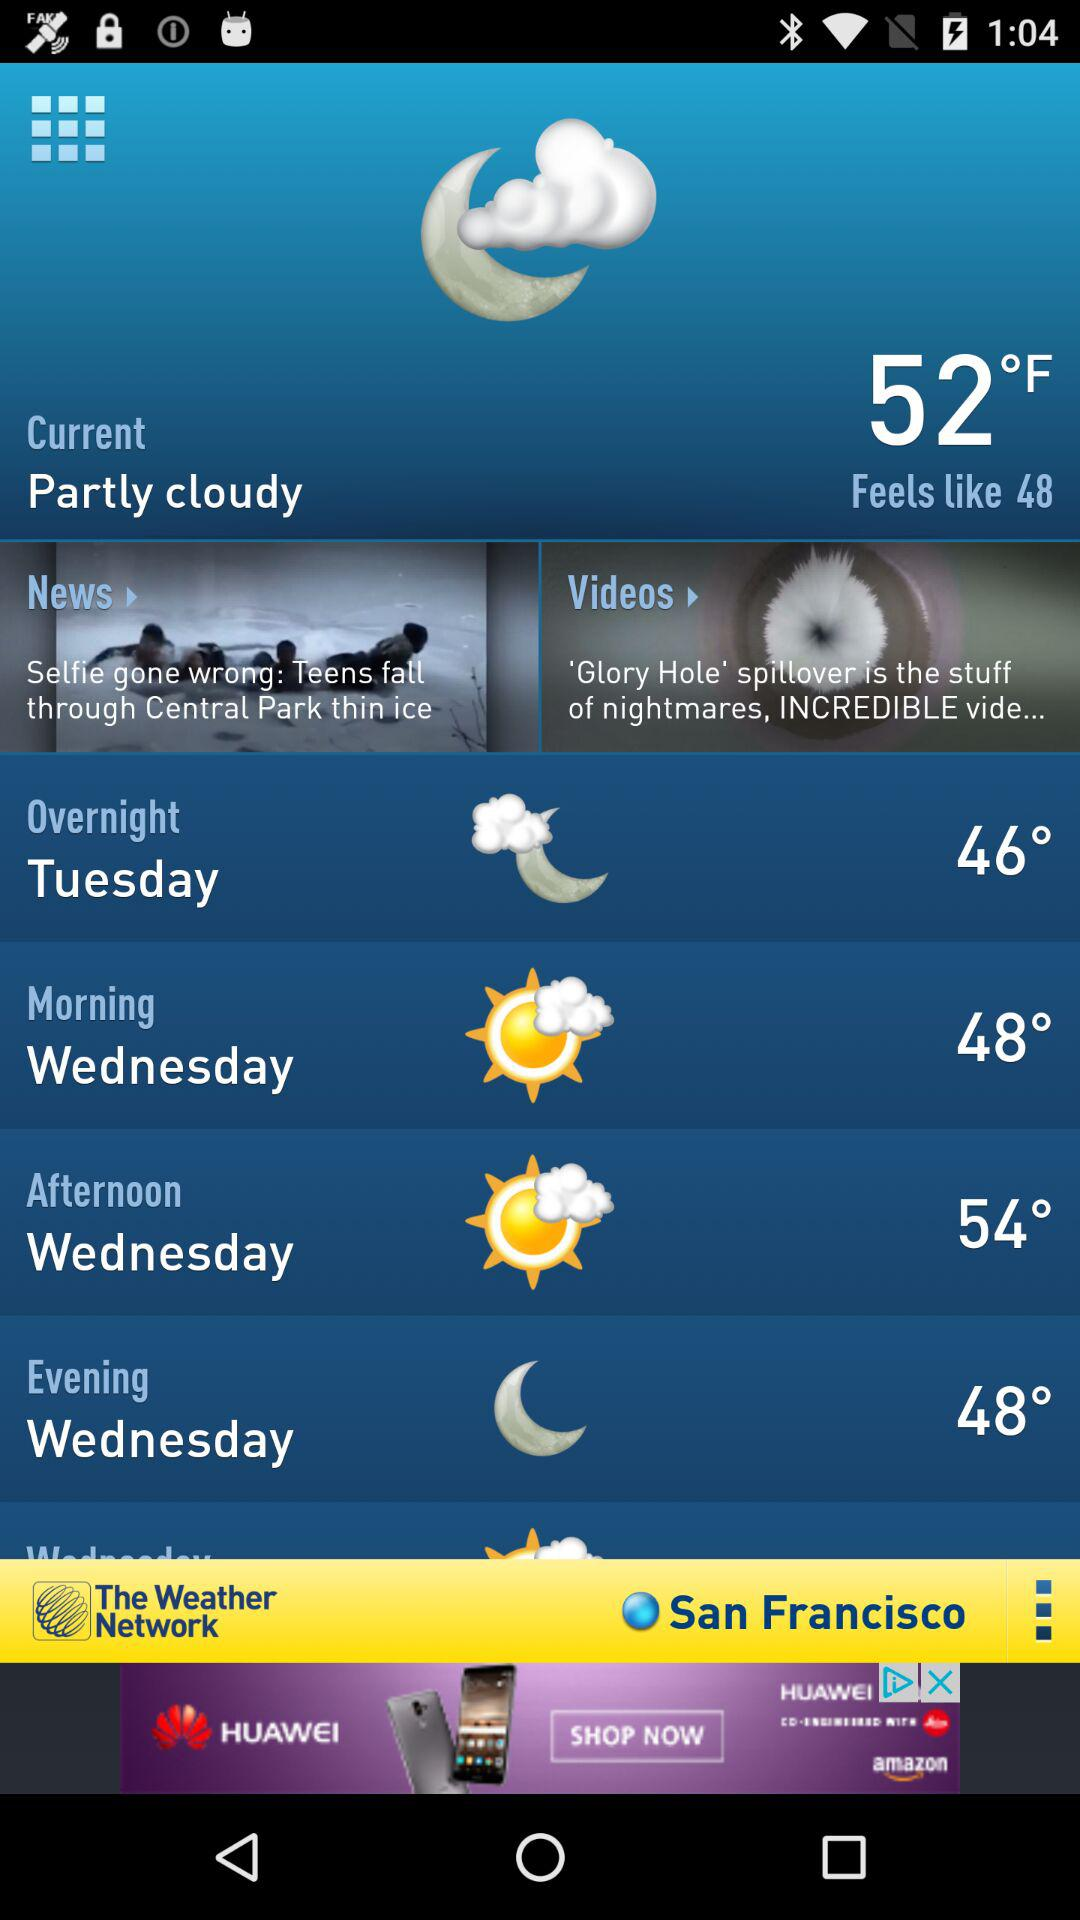What is the morning temperature? The temperature in the morning is 48°. 